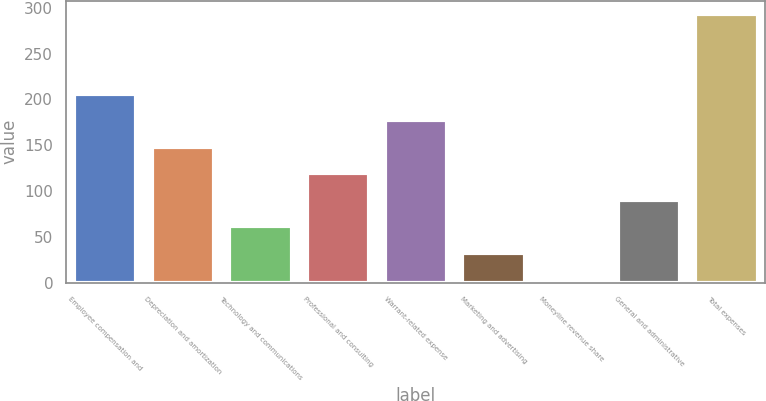<chart> <loc_0><loc_0><loc_500><loc_500><bar_chart><fcel>Employee compensation and<fcel>Depreciation and amortization<fcel>Technology and communications<fcel>Professional and consulting<fcel>Warrant-related expense<fcel>Marketing and advertising<fcel>Moneyline revenue share<fcel>General and administrative<fcel>Total expenses<nl><fcel>206.17<fcel>148.35<fcel>61.62<fcel>119.44<fcel>177.26<fcel>32.71<fcel>3.8<fcel>90.53<fcel>292.9<nl></chart> 